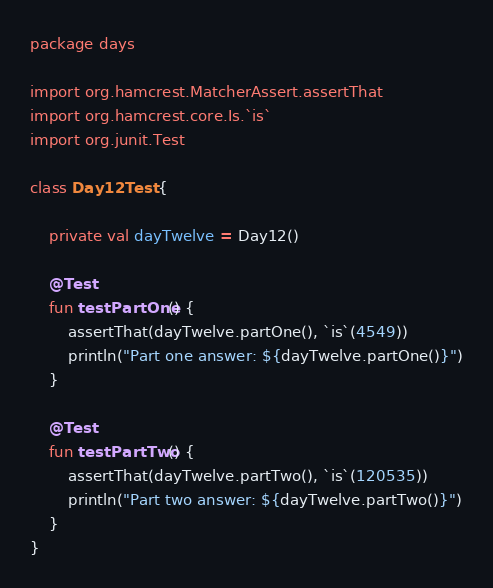Convert code to text. <code><loc_0><loc_0><loc_500><loc_500><_Kotlin_>package days

import org.hamcrest.MatcherAssert.assertThat
import org.hamcrest.core.Is.`is`
import org.junit.Test

class Day12Test {

    private val dayTwelve = Day12()

    @Test
    fun testPartOne() {
        assertThat(dayTwelve.partOne(), `is`(4549))
        println("Part one answer: ${dayTwelve.partOne()}")
    }

    @Test
    fun testPartTwo() {
        assertThat(dayTwelve.partTwo(), `is`(120535))
        println("Part two answer: ${dayTwelve.partTwo()}")
    }
}
</code> 